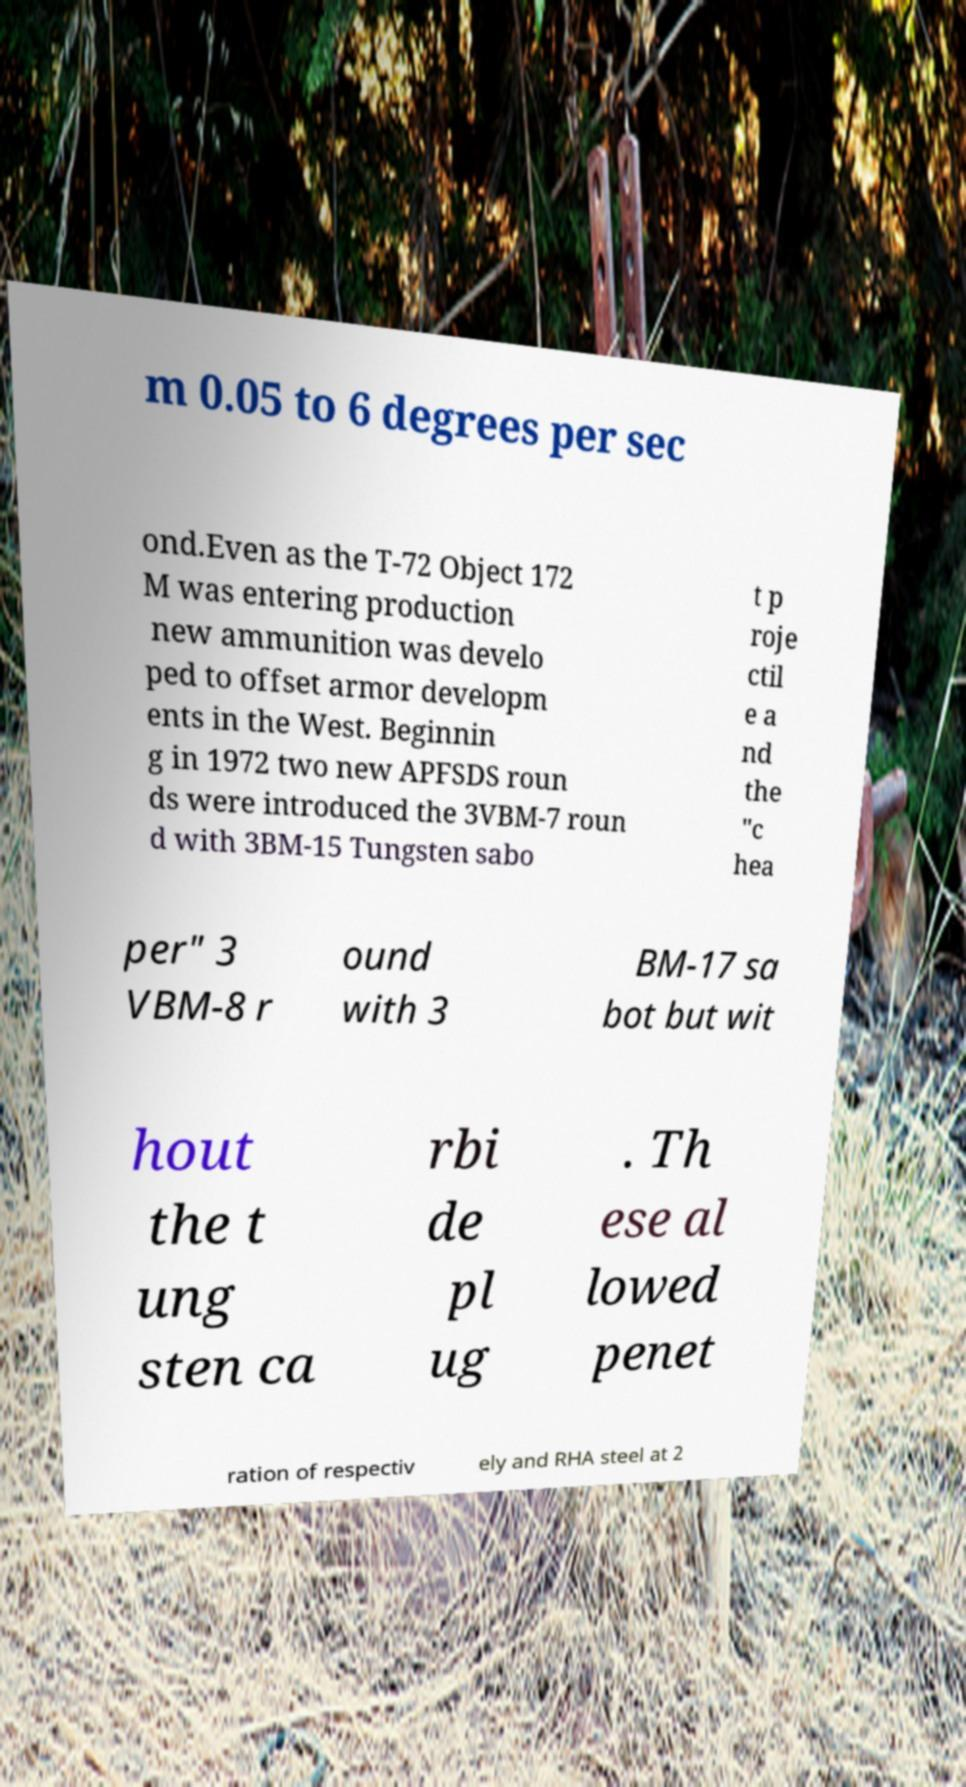Can you read and provide the text displayed in the image?This photo seems to have some interesting text. Can you extract and type it out for me? m 0.05 to 6 degrees per sec ond.Even as the T-72 Object 172 M was entering production new ammunition was develo ped to offset armor developm ents in the West. Beginnin g in 1972 two new APFSDS roun ds were introduced the 3VBM-7 roun d with 3BM-15 Tungsten sabo t p roje ctil e a nd the "c hea per" 3 VBM-8 r ound with 3 BM-17 sa bot but wit hout the t ung sten ca rbi de pl ug . Th ese al lowed penet ration of respectiv ely and RHA steel at 2 